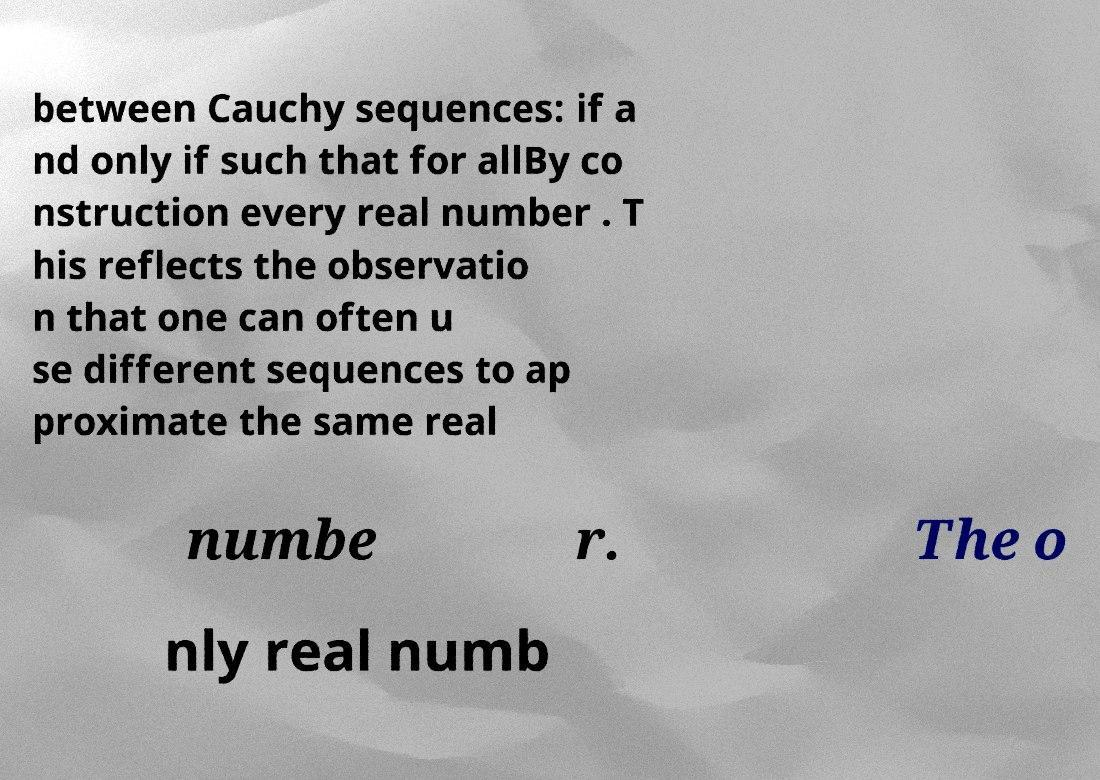Can you accurately transcribe the text from the provided image for me? between Cauchy sequences: if a nd only if such that for allBy co nstruction every real number . T his reflects the observatio n that one can often u se different sequences to ap proximate the same real numbe r. The o nly real numb 